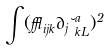Convert formula to latex. <formula><loc_0><loc_0><loc_500><loc_500>\int ( \epsilon _ { i j k } \partial _ { j } \lambda ^ { a } _ { k L } ) ^ { 2 }</formula> 